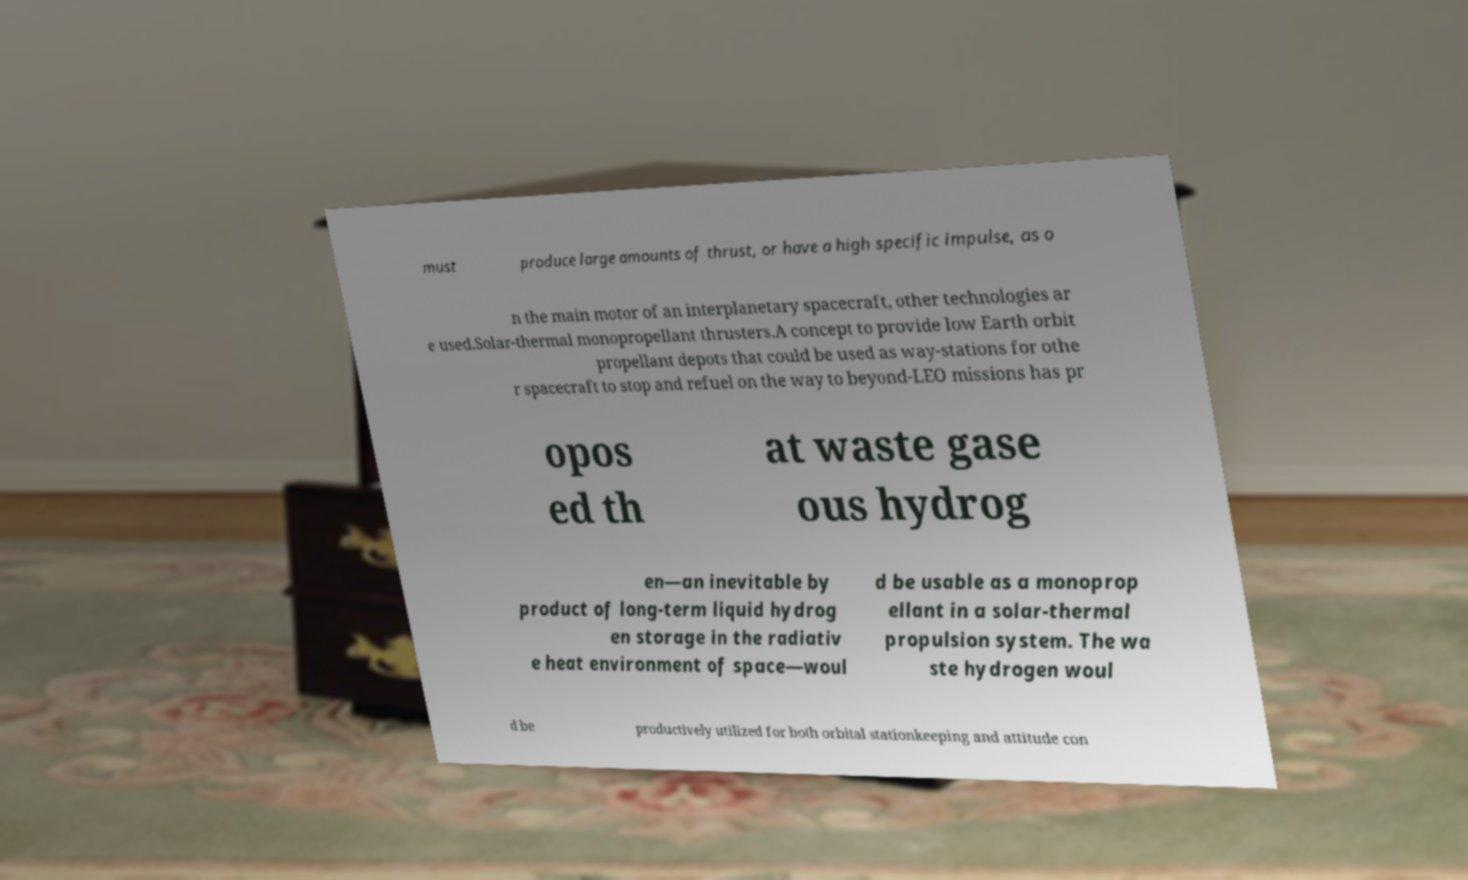There's text embedded in this image that I need extracted. Can you transcribe it verbatim? must produce large amounts of thrust, or have a high specific impulse, as o n the main motor of an interplanetary spacecraft, other technologies ar e used.Solar-thermal monopropellant thrusters.A concept to provide low Earth orbit propellant depots that could be used as way-stations for othe r spacecraft to stop and refuel on the way to beyond-LEO missions has pr opos ed th at waste gase ous hydrog en—an inevitable by product of long-term liquid hydrog en storage in the radiativ e heat environment of space—woul d be usable as a monoprop ellant in a solar-thermal propulsion system. The wa ste hydrogen woul d be productively utilized for both orbital stationkeeping and attitude con 